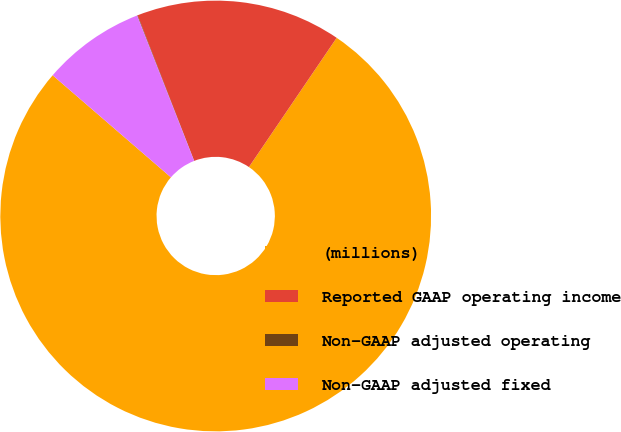Convert chart to OTSL. <chart><loc_0><loc_0><loc_500><loc_500><pie_chart><fcel>(millions)<fcel>Reported GAAP operating income<fcel>Non-GAAP adjusted operating<fcel>Non-GAAP adjusted fixed<nl><fcel>76.84%<fcel>15.4%<fcel>0.04%<fcel>7.72%<nl></chart> 